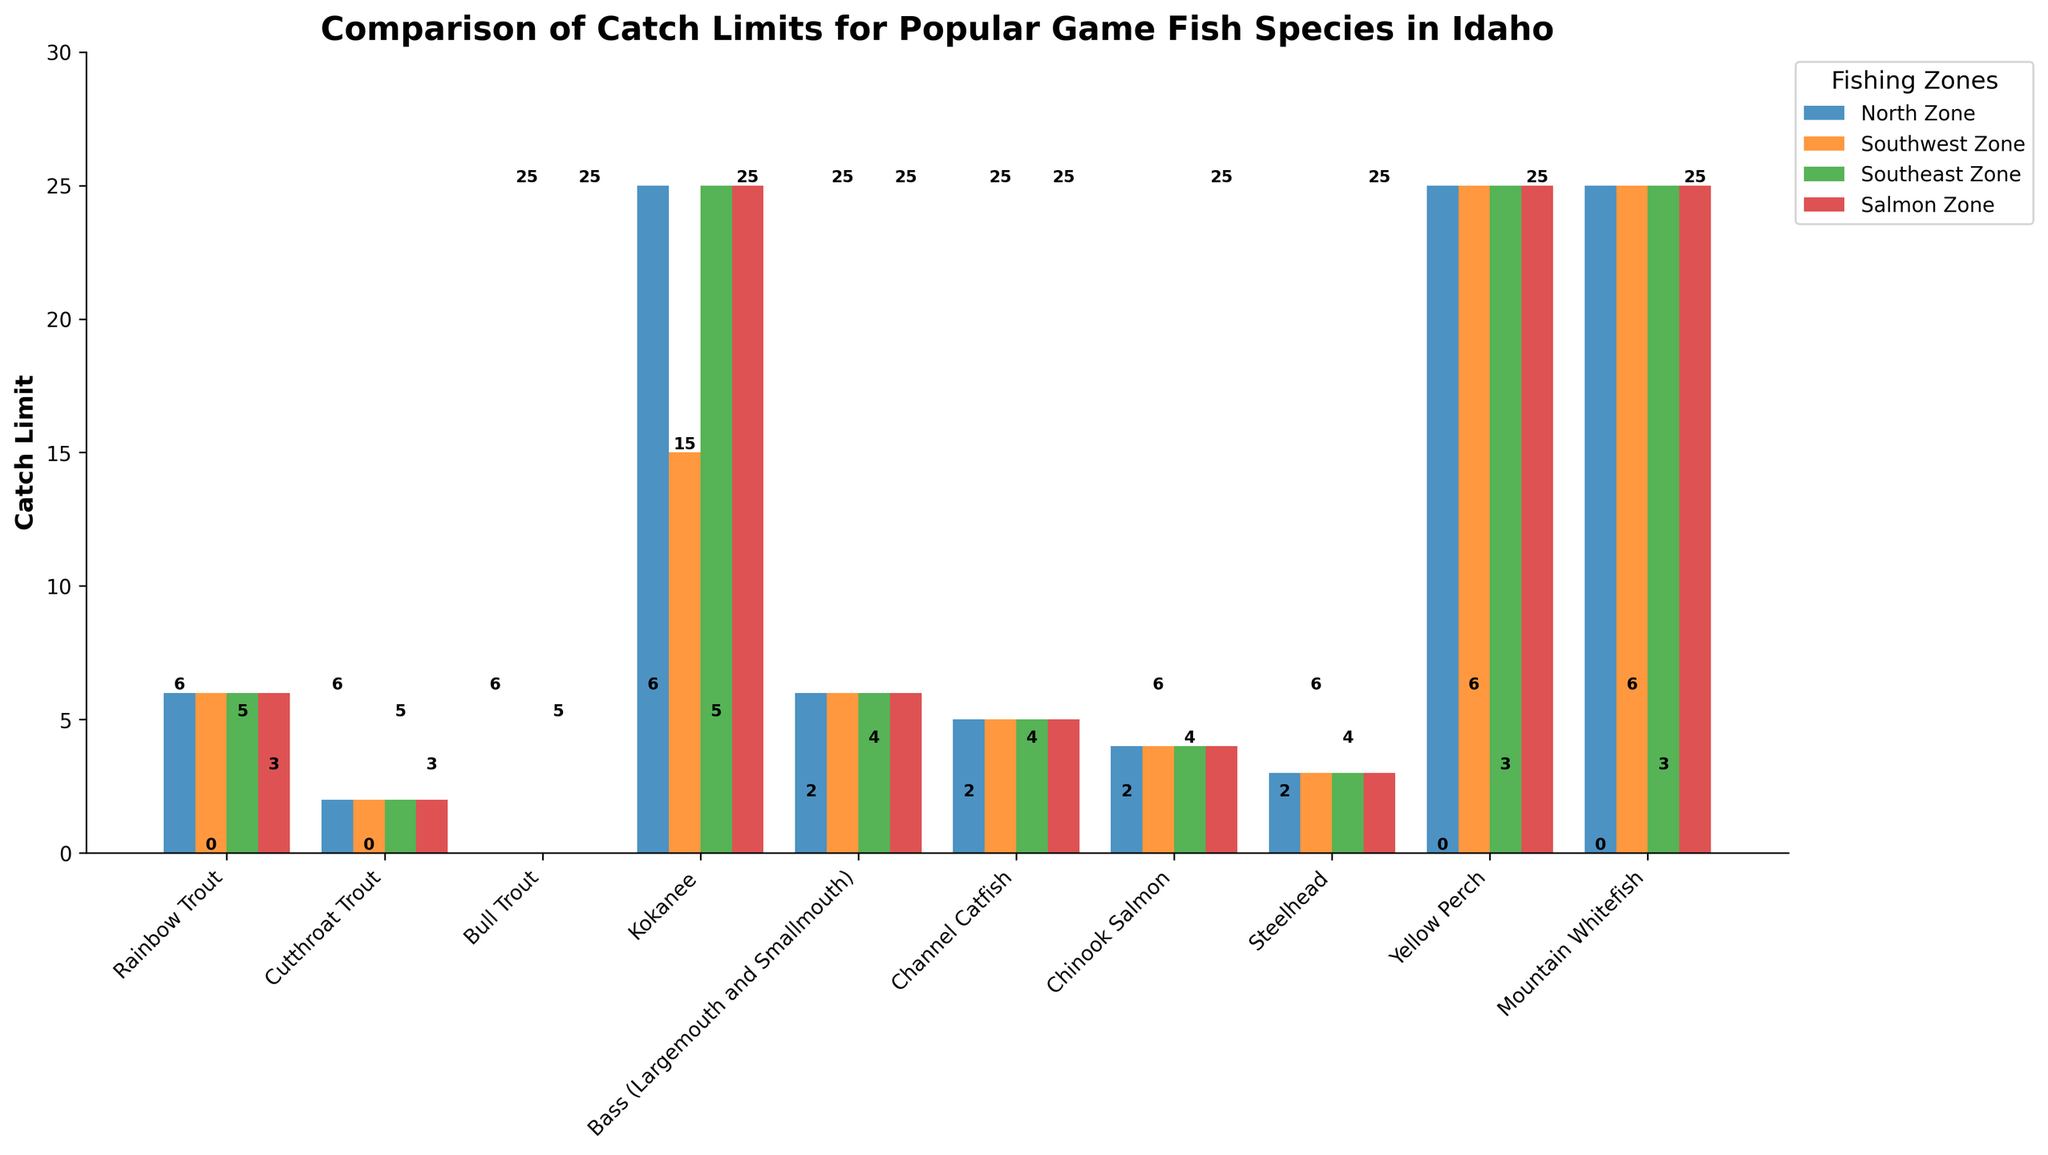What's the catch limit for Mountain Whitefish in the Southeast Zone? The figure displays bar heights representing catch limits for different species across zones. Locate the bar for Mountain Whitefish in the Southeast Zone. The bar for Mountain Whitefish is high, matching the y-axis label of 25.
Answer: 25 Which species has the highest catch limit in the Salmon Zone? Identify the tallest bar in the Salmon Zone, which represents the highest catch limit. Kokanee and Yellow Perch have tall bars reaching up to the 25 unit mark. The catch limit of 25 is the highest in this zone.
Answer: Kokanee and Yellow Perch What's the difference in Kokanee catch limits between the Southwest and North Zones? Look at the height of the Kokanee bars for both the Southwest and North Zones. The bar for the Southwest Zone is at 15, and the North Zone is at 25. Calculate the difference: 25 - 15.
Answer: 10 Do Cutthroat Trout have the same catch limit across all zones? Observe the height of the bars for Cutthroat Trout across all zones. All bars are at the same height, corresponding to the catch limit of 2. Since they are equal, the catch limits are the same across all zones.
Answer: Yes How much higher is the Rainbow Trout catch limit compared to the Bull Trout catch limit in any zone? Compare the height of the Rainbow Trout and Bull Trout bars. The Rainbow Trout bar reaches up to 6, while the Bull Trout bar is at 0. Subtract the heights: 6 - 0.
Answer: 6 Which species have a zero catch limit in all zones? Identify the species with bars reaching the y-axis value of 0 across all zones. The Bull Trout bars are all at 0, indicating zero catch limits across all zones.
Answer: Bull Trout Are there any zones where the catch limits for Channel Catfish and Steelhead are equal? Compare the height of the bars for Channel Catfish and Steelhead in each zone. Both species have bars at 5 and 3 respectively in every zone. This shows consistency across all zones.
Answer: No What's the total catch limit for Rainbow Trout across all zones? Note the catch limit for Rainbow Trout in each zone is 6. Sum these values: 6 (North) + 6 (Southwest) + 6 (Southeast) + 6 (Salmon).
Answer: 24 Is the Yellow Perch catch limit the same as the Mountain Whitefish catch limit in the Southwest Zone? Compare the height of the bars for Yellow Perch and Mountain Whitefish in the Southwest Zone. Both bars reach up to the 25 mark, indicating equal limits.
Answer: Yes Which species has the second highest catch limit overall and in which zones? Identify the species with the second tallest bars for each zone. After Yellow Perch and Mountain Whitefish at 25, the next tallest bars belong to Kokanee (15 in the Southwest Zone, 25 elsewhere).
Answer: Kokanee (North, Southeast, Salmon Zones: 25), Kokanee (Southwest Zone: 15) 